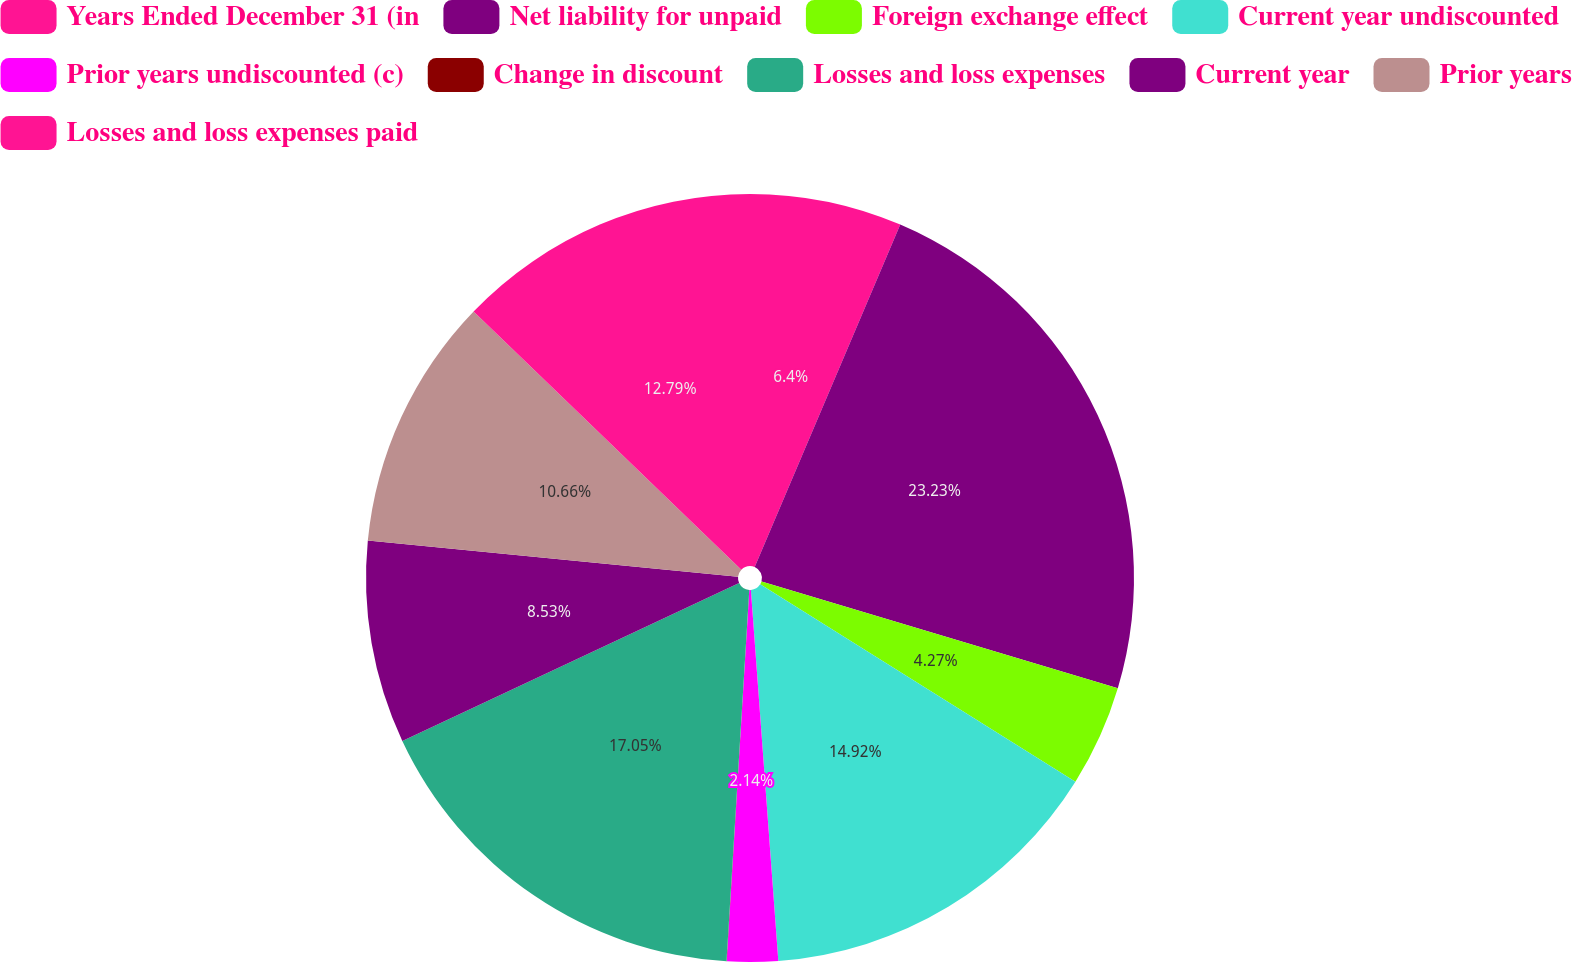Convert chart to OTSL. <chart><loc_0><loc_0><loc_500><loc_500><pie_chart><fcel>Years Ended December 31 (in<fcel>Net liability for unpaid<fcel>Foreign exchange effect<fcel>Current year undiscounted<fcel>Prior years undiscounted (c)<fcel>Change in discount<fcel>Losses and loss expenses<fcel>Current year<fcel>Prior years<fcel>Losses and loss expenses paid<nl><fcel>6.4%<fcel>23.24%<fcel>4.27%<fcel>14.92%<fcel>2.14%<fcel>0.01%<fcel>17.05%<fcel>8.53%<fcel>10.66%<fcel>12.79%<nl></chart> 